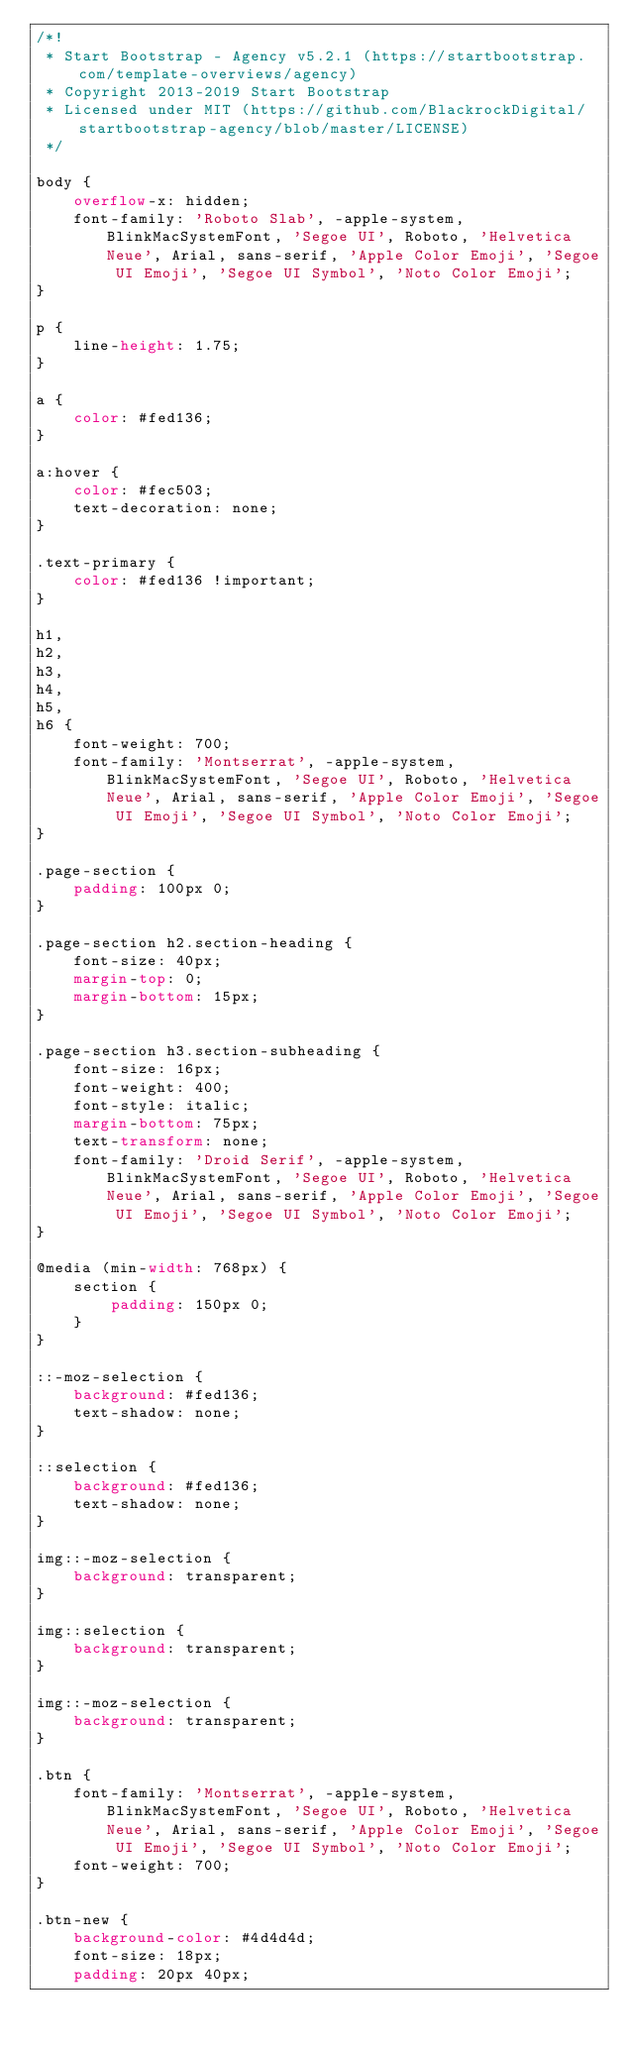<code> <loc_0><loc_0><loc_500><loc_500><_CSS_>/*!
 * Start Bootstrap - Agency v5.2.1 (https://startbootstrap.com/template-overviews/agency)
 * Copyright 2013-2019 Start Bootstrap
 * Licensed under MIT (https://github.com/BlackrockDigital/startbootstrap-agency/blob/master/LICENSE)
 */

body {
    overflow-x: hidden;
    font-family: 'Roboto Slab', -apple-system, BlinkMacSystemFont, 'Segoe UI', Roboto, 'Helvetica Neue', Arial, sans-serif, 'Apple Color Emoji', 'Segoe UI Emoji', 'Segoe UI Symbol', 'Noto Color Emoji';
}

p {
    line-height: 1.75;
}

a {
    color: #fed136;
}

a:hover {
    color: #fec503;
    text-decoration: none;
}

.text-primary {
    color: #fed136 !important;
}

h1,
h2,
h3,
h4,
h5,
h6 {
    font-weight: 700;
    font-family: 'Montserrat', -apple-system, BlinkMacSystemFont, 'Segoe UI', Roboto, 'Helvetica Neue', Arial, sans-serif, 'Apple Color Emoji', 'Segoe UI Emoji', 'Segoe UI Symbol', 'Noto Color Emoji';
}

.page-section {
    padding: 100px 0;
}

.page-section h2.section-heading {
    font-size: 40px;
    margin-top: 0;
    margin-bottom: 15px;
}

.page-section h3.section-subheading {
    font-size: 16px;
    font-weight: 400;
    font-style: italic;
    margin-bottom: 75px;
    text-transform: none;
    font-family: 'Droid Serif', -apple-system, BlinkMacSystemFont, 'Segoe UI', Roboto, 'Helvetica Neue', Arial, sans-serif, 'Apple Color Emoji', 'Segoe UI Emoji', 'Segoe UI Symbol', 'Noto Color Emoji';
}

@media (min-width: 768px) {
    section {
        padding: 150px 0;
    }
}

::-moz-selection {
    background: #fed136;
    text-shadow: none;
}

::selection {
    background: #fed136;
    text-shadow: none;
}

img::-moz-selection {
    background: transparent;
}

img::selection {
    background: transparent;
}

img::-moz-selection {
    background: transparent;
}

.btn {
    font-family: 'Montserrat', -apple-system, BlinkMacSystemFont, 'Segoe UI', Roboto, 'Helvetica Neue', Arial, sans-serif, 'Apple Color Emoji', 'Segoe UI Emoji', 'Segoe UI Symbol', 'Noto Color Emoji';
    font-weight: 700;
}

.btn-new {
    background-color: #4d4d4d;
    font-size: 18px;
    padding: 20px 40px;</code> 